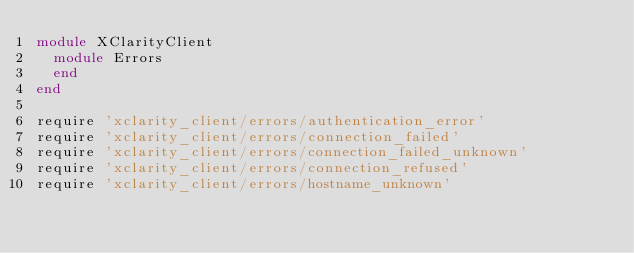<code> <loc_0><loc_0><loc_500><loc_500><_Ruby_>module XClarityClient
  module Errors
  end
end

require 'xclarity_client/errors/authentication_error'
require 'xclarity_client/errors/connection_failed'
require 'xclarity_client/errors/connection_failed_unknown'
require 'xclarity_client/errors/connection_refused'
require 'xclarity_client/errors/hostname_unknown'
</code> 